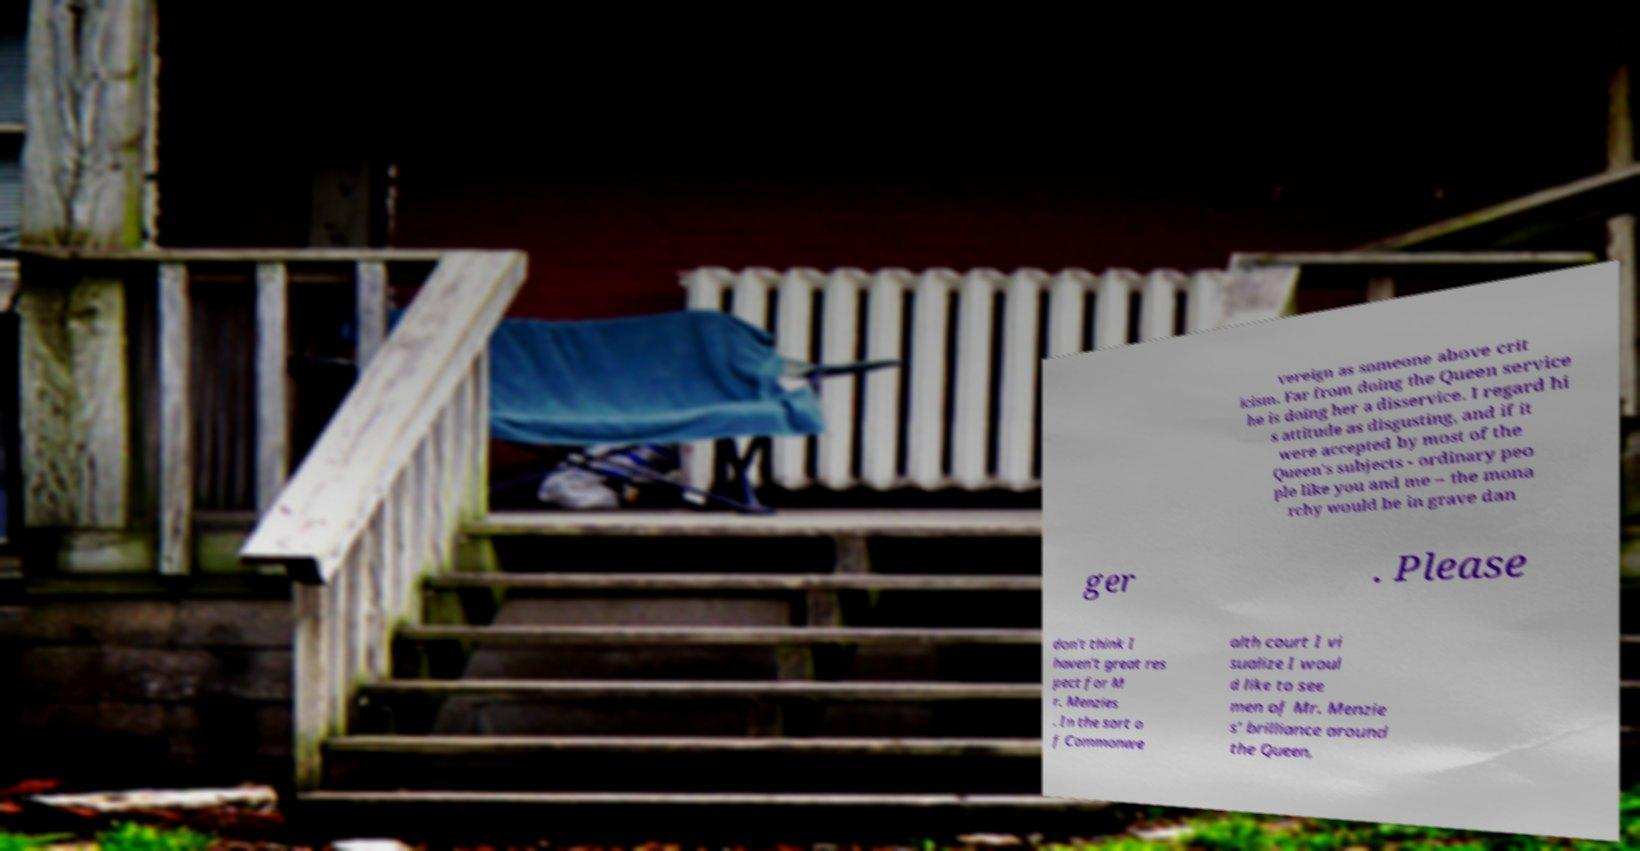There's text embedded in this image that I need extracted. Can you transcribe it verbatim? vereign as someone above crit icism. Far from doing the Queen service he is doing her a disservice. I regard hi s attitude as disgusting, and if it were accepted by most of the Queen's subjects - ordinary peo ple like you and me – the mona rchy would be in grave dan ger . Please don't think I haven't great res pect for M r. Menzies . In the sort o f Commonwe alth court I vi sualize I woul d like to see men of Mr. Menzie s' brilliance around the Queen, 